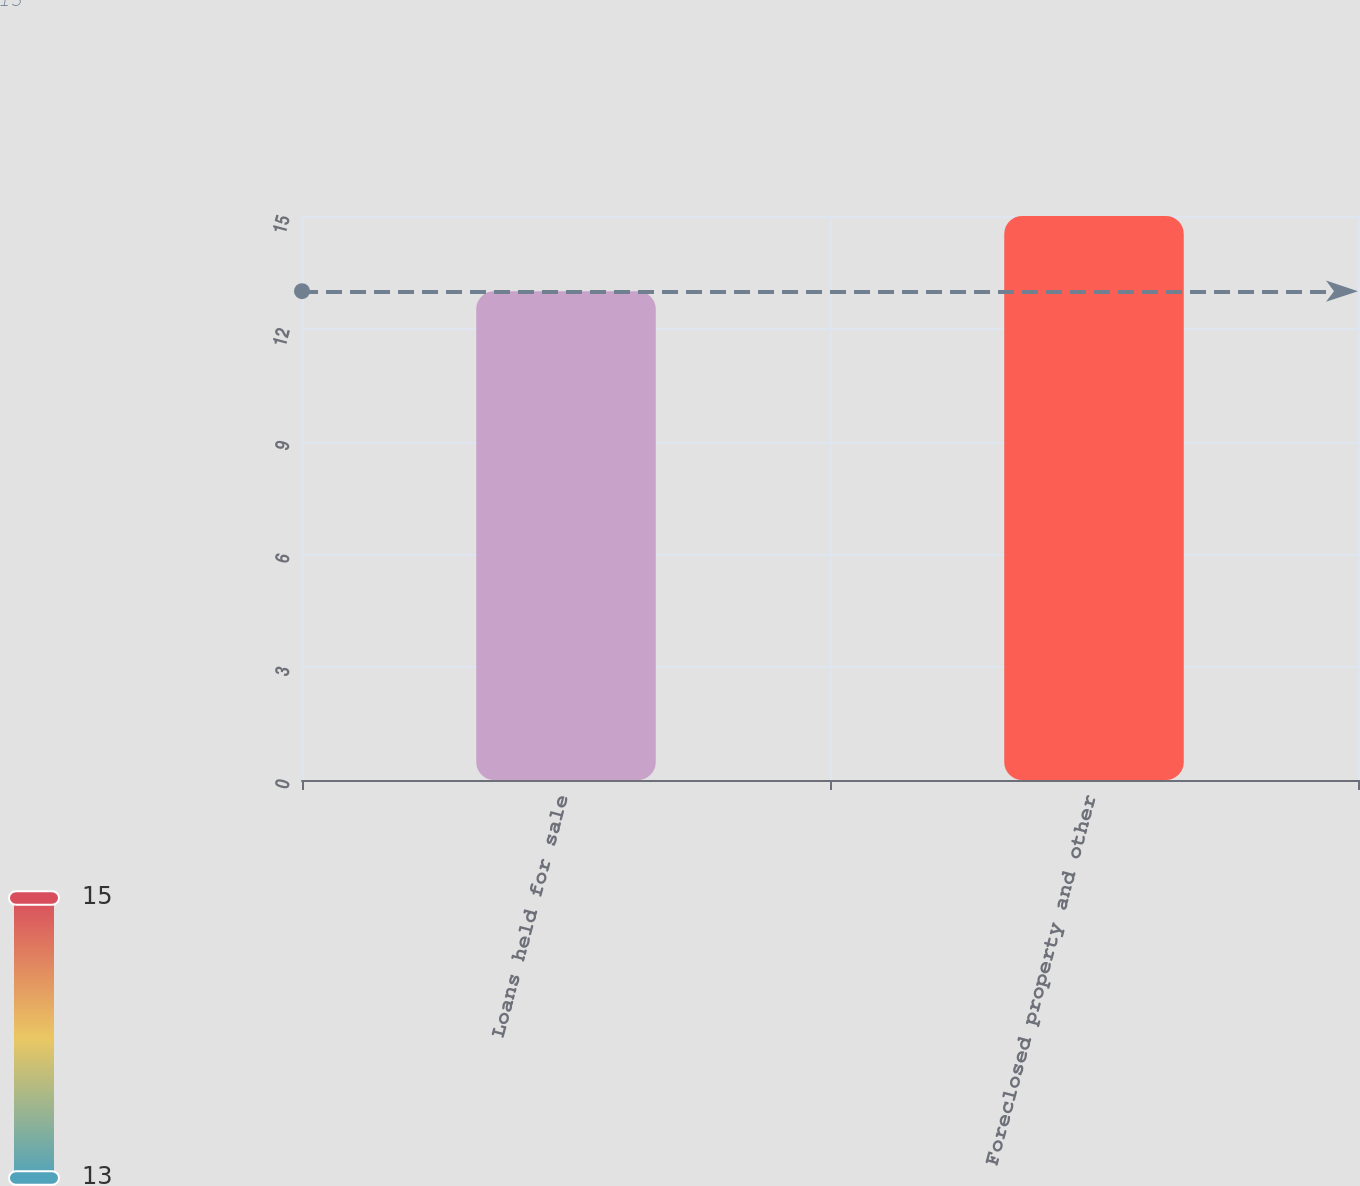<chart> <loc_0><loc_0><loc_500><loc_500><bar_chart><fcel>Loans held for sale<fcel>Foreclosed property and other<nl><fcel>13<fcel>15<nl></chart> 